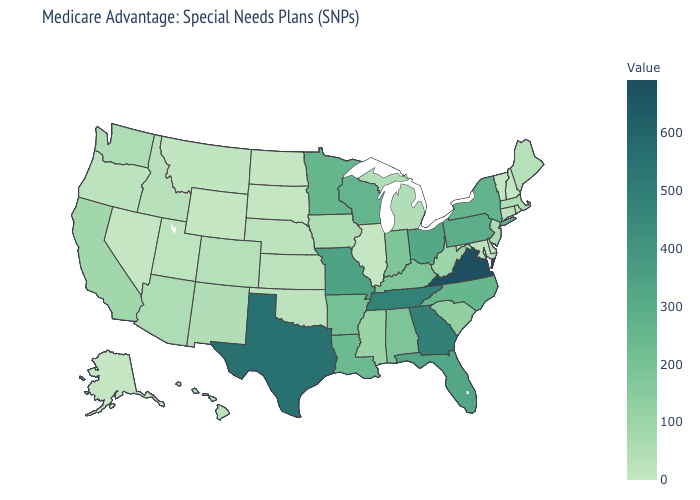Which states hav the highest value in the Northeast?
Be succinct. Pennsylvania. Which states have the highest value in the USA?
Answer briefly. Virginia. Among the states that border Iowa , does Missouri have the highest value?
Answer briefly. Yes. Which states have the highest value in the USA?
Write a very short answer. Virginia. Does North Dakota have the highest value in the USA?
Answer briefly. No. 